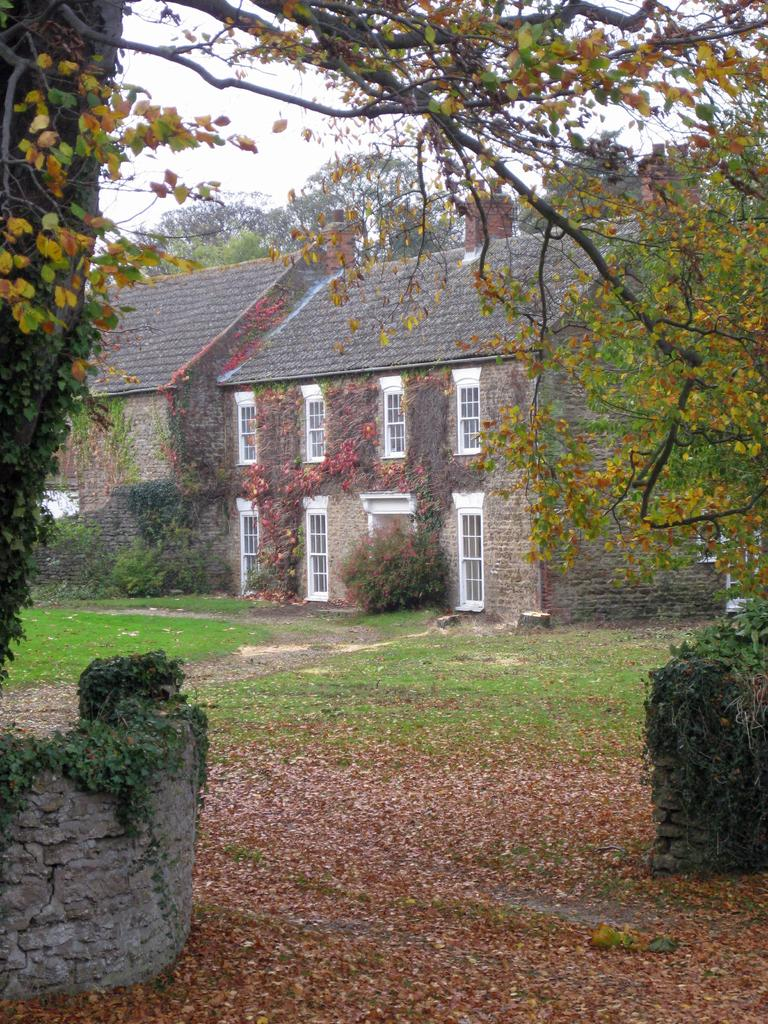What type of structure is in the image? There is a house in the image. What feature can be seen on the house? The house has windows. What natural elements are present in the image? Dry leaves, grass, and trees are visible in the image. What part of the natural environment is visible in the image? The sky is visible in the image. Where is the clock located in the image? There is no clock present in the image. What type of quiver can be seen attached to the trees in the image? There is no quiver present in the image; only trees are visible. 